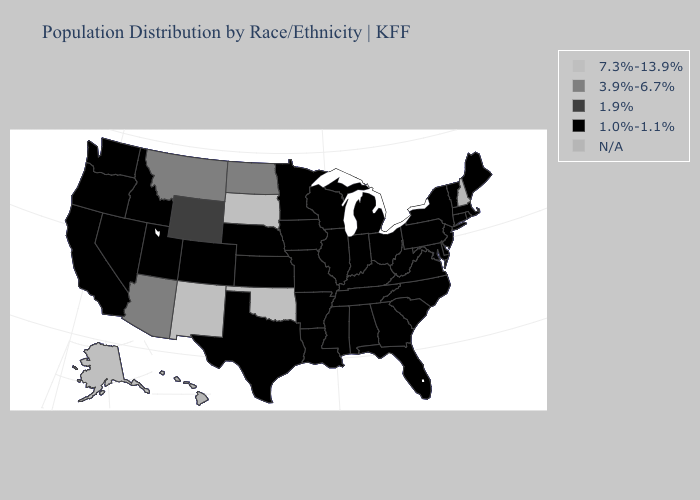What is the value of North Dakota?
Answer briefly. 3.9%-6.7%. Does the map have missing data?
Write a very short answer. Yes. Name the states that have a value in the range 3.9%-6.7%?
Give a very brief answer. Arizona, Montana, North Dakota. What is the highest value in the USA?
Write a very short answer. 7.3%-13.9%. Name the states that have a value in the range 1.9%?
Quick response, please. Wyoming. Does North Carolina have the lowest value in the USA?
Short answer required. Yes. Does the first symbol in the legend represent the smallest category?
Answer briefly. No. What is the value of New York?
Concise answer only. 1.0%-1.1%. What is the highest value in states that border Wyoming?
Short answer required. 7.3%-13.9%. Among the states that border Idaho , which have the lowest value?
Keep it brief. Nevada, Oregon, Utah, Washington. Name the states that have a value in the range 7.3%-13.9%?
Concise answer only. Alaska, New Mexico, Oklahoma, South Dakota. Does South Dakota have the highest value in the USA?
Answer briefly. Yes. Does West Virginia have the lowest value in the USA?
Be succinct. Yes. Does Utah have the highest value in the USA?
Short answer required. No. 